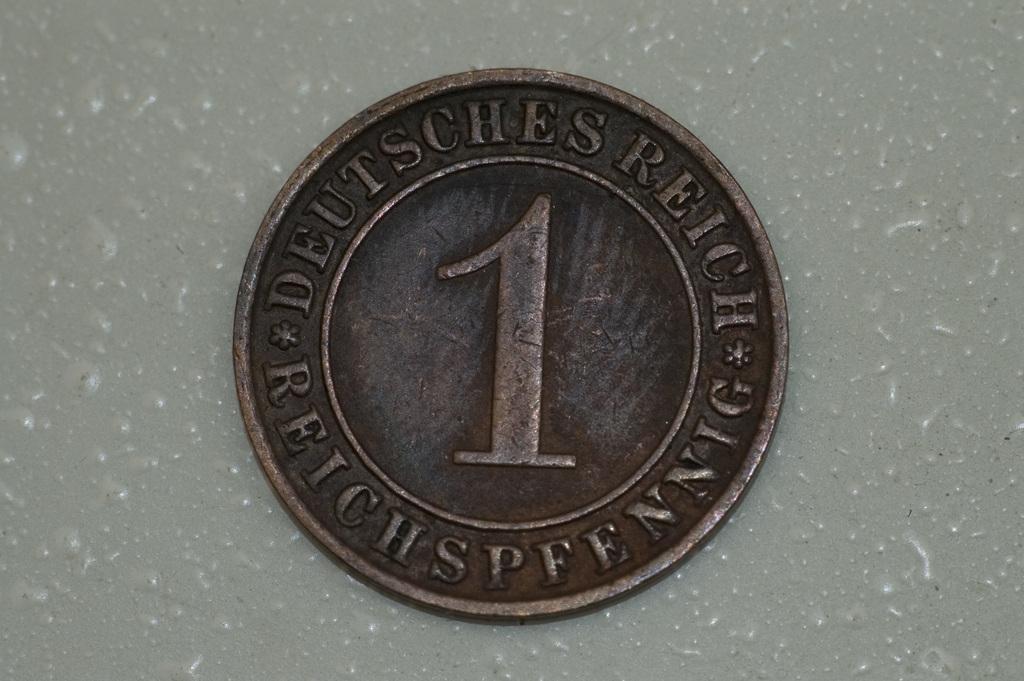Describe this image in one or two sentences. We can see coin on the surface. 